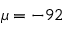<formula> <loc_0><loc_0><loc_500><loc_500>\mu = - 9 2</formula> 